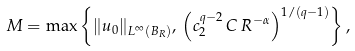Convert formula to latex. <formula><loc_0><loc_0><loc_500><loc_500>M = \max \left \{ \| u _ { 0 } \| _ { L ^ { \infty } ( B _ { R } ) } , \, \left ( c _ { 2 } ^ { q - 2 } \, C \, R ^ { - \alpha } \right ) ^ { 1 / ( q - 1 ) } \right \} ,</formula> 